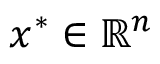Convert formula to latex. <formula><loc_0><loc_0><loc_500><loc_500>x ^ { * } \in \mathbb { R } ^ { n }</formula> 